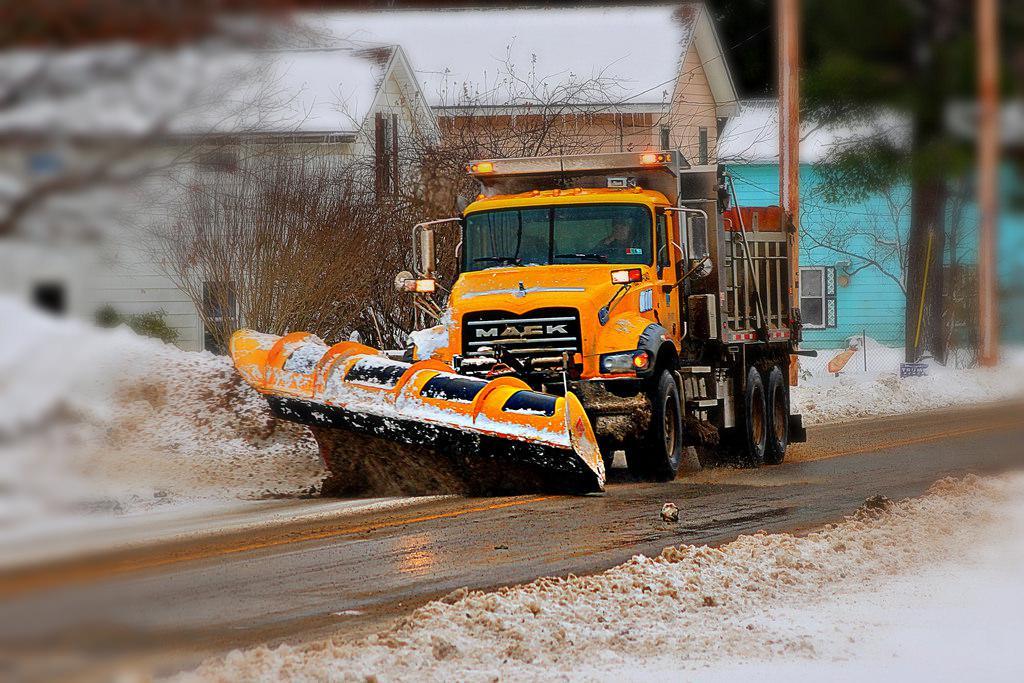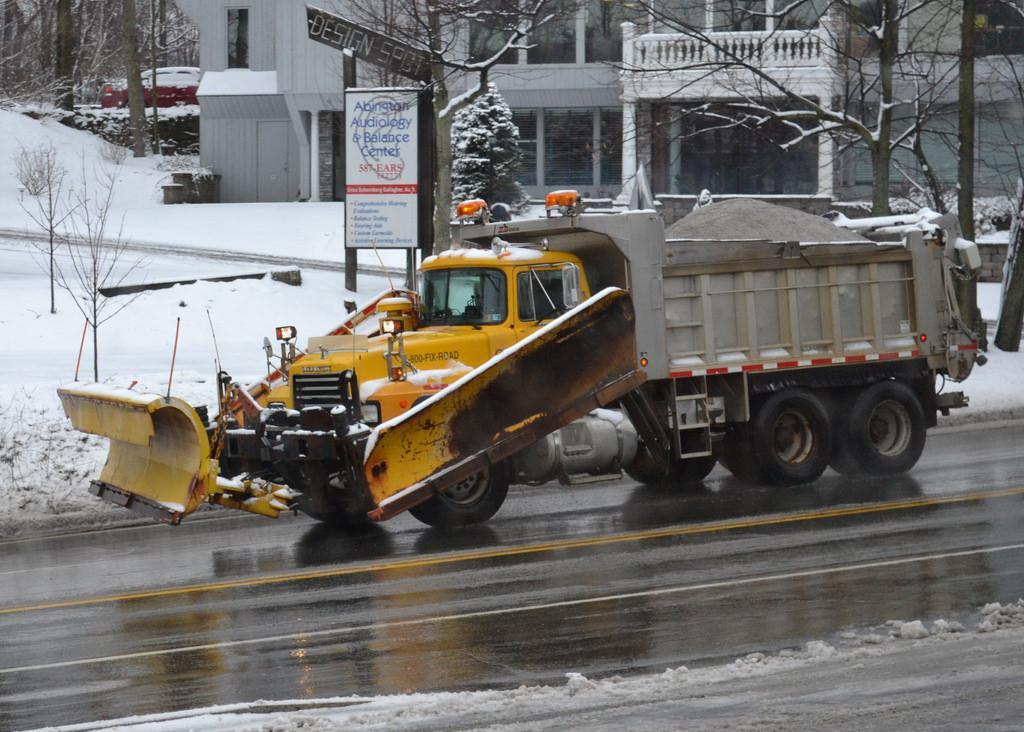The first image is the image on the left, the second image is the image on the right. Considering the images on both sides, is "There are no fewer than 4 vehicles on the road." valid? Answer yes or no. No. The first image is the image on the left, the second image is the image on the right. For the images displayed, is the sentence "The left and right image contains a total of three snow trucks." factually correct? Answer yes or no. No. 